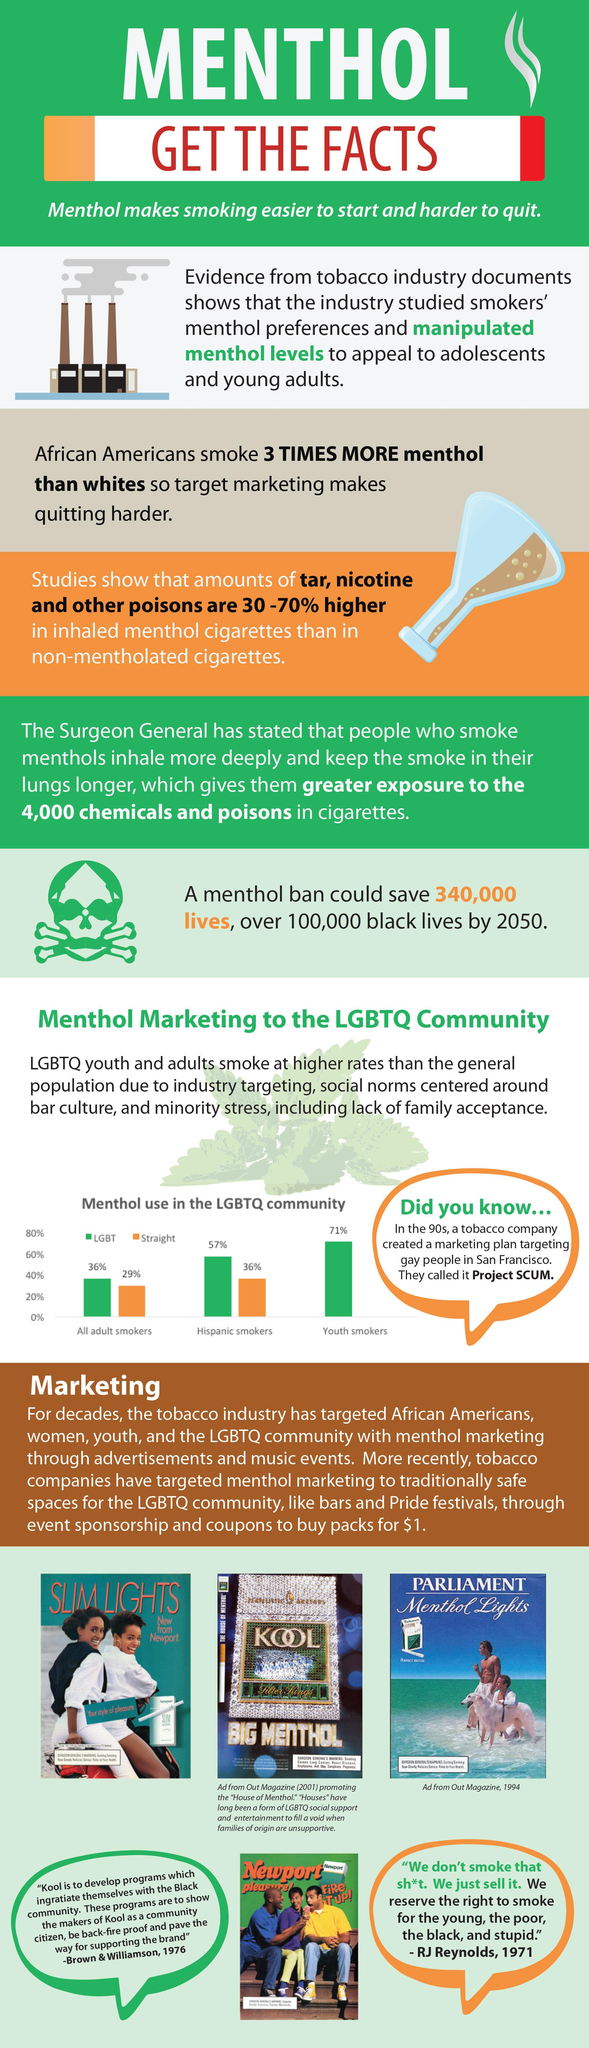Identify some key points in this picture. African Americans are more likely to smoke menthol cigarettes than whites, according to research. According to a study, among adult smokers who use menthol cigarettes, 36% identify as members of the LGBT community. 